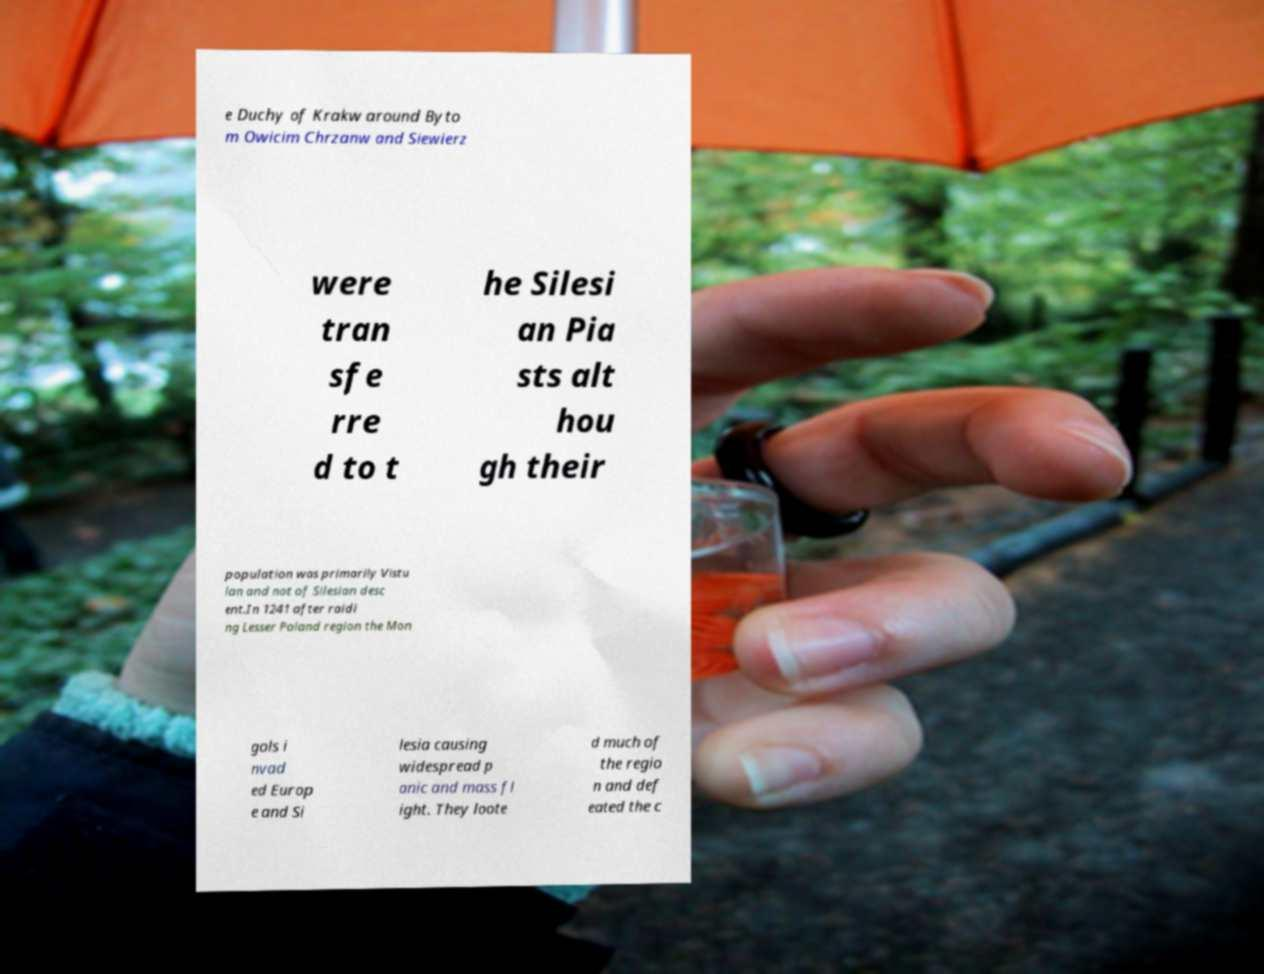Please identify and transcribe the text found in this image. e Duchy of Krakw around Byto m Owicim Chrzanw and Siewierz were tran sfe rre d to t he Silesi an Pia sts alt hou gh their population was primarily Vistu lan and not of Silesian desc ent.In 1241 after raidi ng Lesser Poland region the Mon gols i nvad ed Europ e and Si lesia causing widespread p anic and mass fl ight. They loote d much of the regio n and def eated the c 